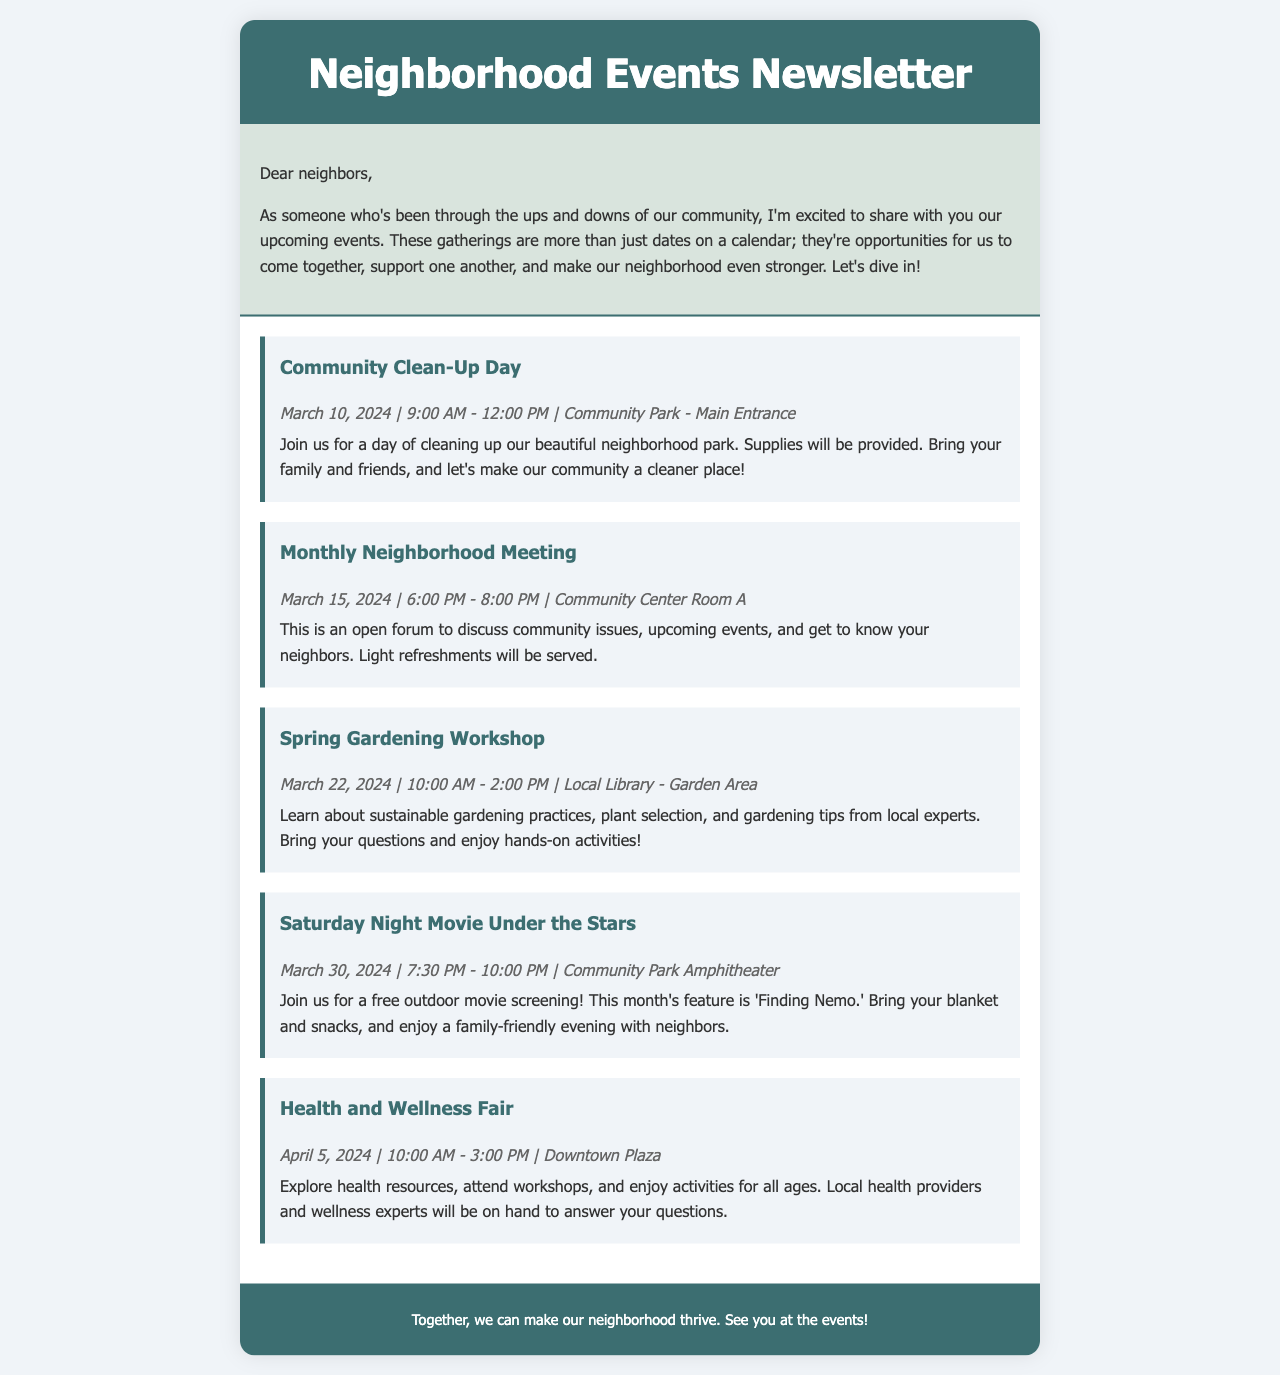What is the date of the Community Clean-Up Day? The date of the Community Clean-Up Day is specified in the document as March 10, 2024.
Answer: March 10, 2024 What time does the Monthly Neighborhood Meeting start? The starting time of the Monthly Neighborhood Meeting is mentioned as 6:00 PM.
Answer: 6:00 PM Where will the Spring Gardening Workshop take place? The location of the Spring Gardening Workshop is detailed in the document as the Local Library - Garden Area.
Answer: Local Library - Garden Area Which movie will be shown at the Saturday Night Movie Under the Stars? The title of the movie scheduled for the outdoor screening is 'Finding Nemo.'
Answer: Finding Nemo How long is the Health and Wellness Fair scheduled to last? The document provides the hours of the Health and Wellness Fair as 10:00 AM to 3:00 PM, which is a duration of 5 hours.
Answer: 5 hours What type of activities can attendees expect at the Health and Wellness Fair? The document mentions that participants can explore health resources and attend workshops, indicating the type of activities available.
Answer: Health resources and workshops What is the main purpose of the Monthly Neighborhood Meeting? The document states that the purpose of the Monthly Neighborhood Meeting is to discuss community issues and build connections, highlighting its community-building role.
Answer: Discuss community issues and get to know your neighbors What is the overall theme of the newsletter? The theme of the newsletter focuses on community engagement and participation through shared events and gatherings.
Answer: Community engagement and participation 